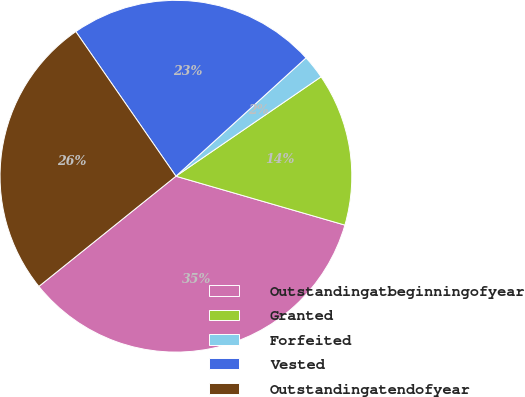<chart> <loc_0><loc_0><loc_500><loc_500><pie_chart><fcel>Outstandingatbeginningofyear<fcel>Granted<fcel>Forfeited<fcel>Vested<fcel>Outstandingatendofyear<nl><fcel>34.74%<fcel>14.04%<fcel>2.19%<fcel>22.89%<fcel>26.14%<nl></chart> 